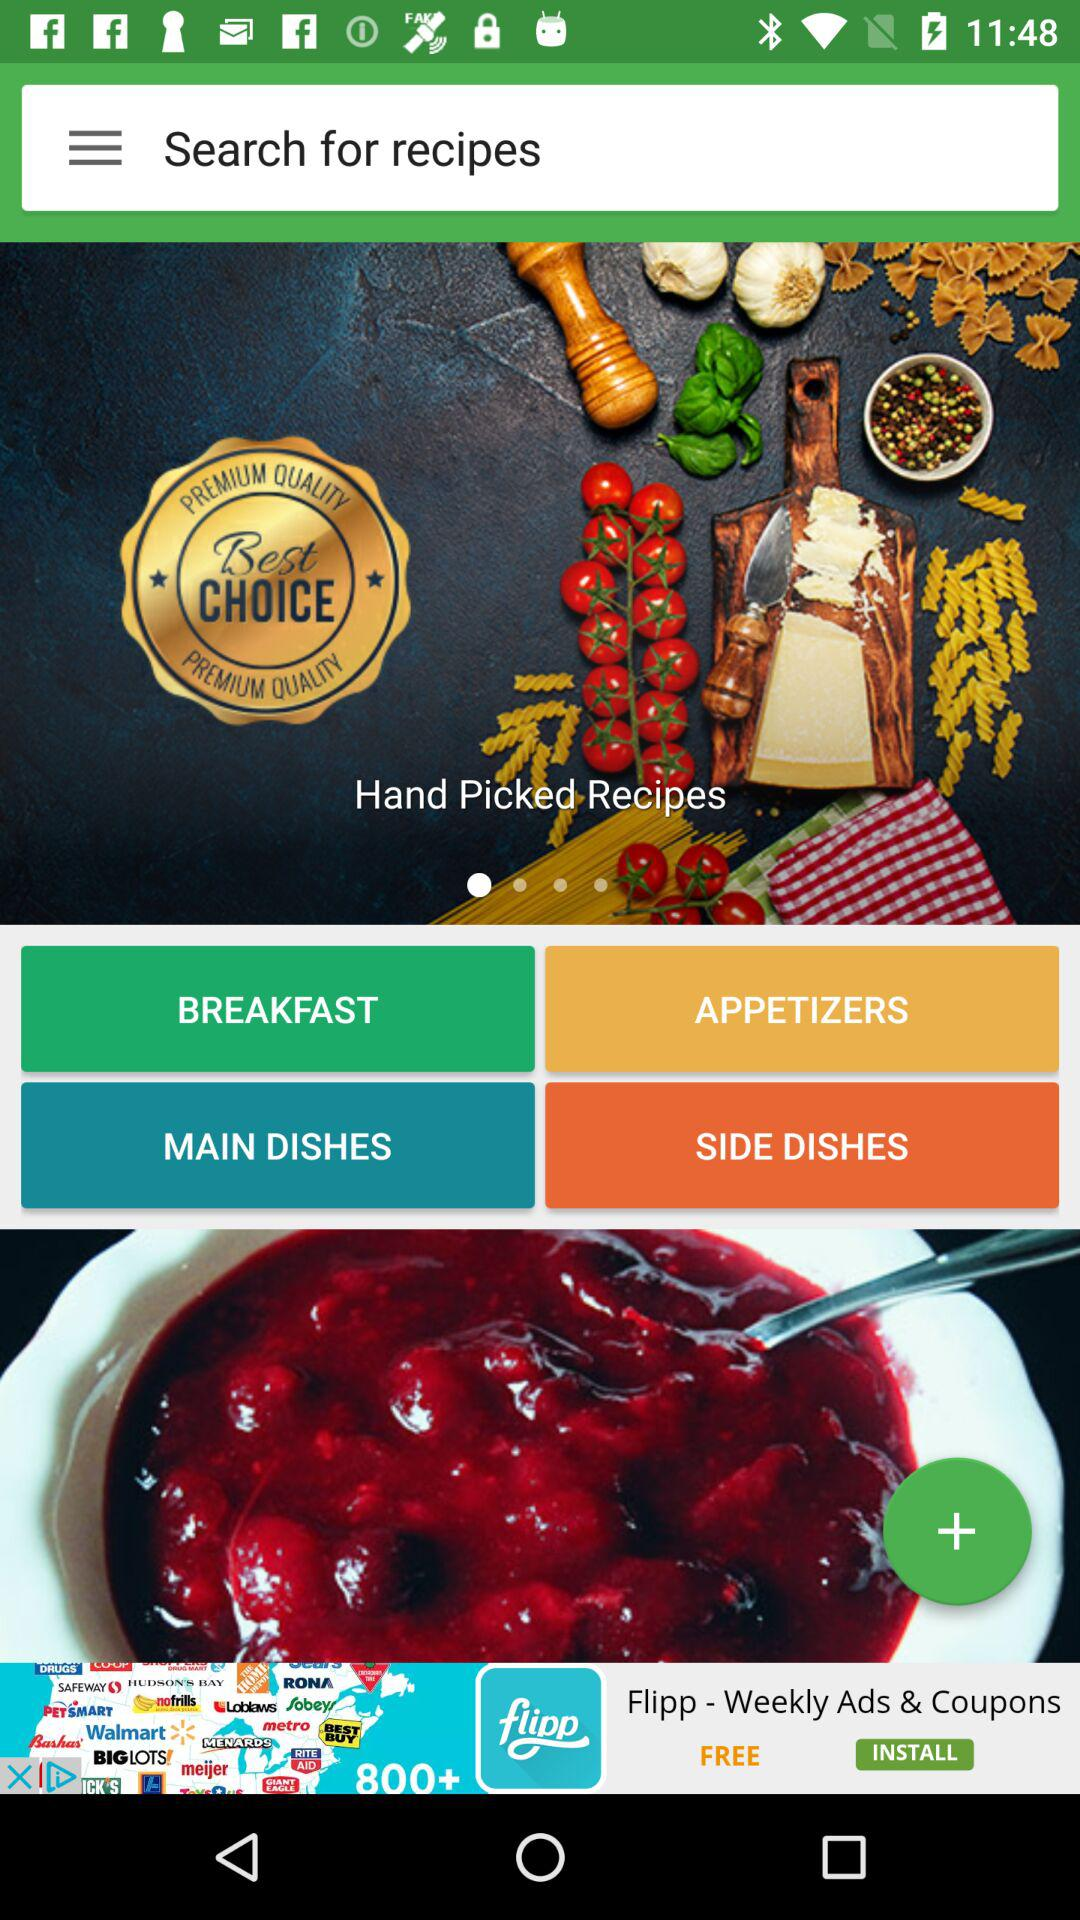What are the options in the menu? The options in the menu are "BREAKFAST", "APPETIZERS", "MAIN DISHES", and "SIDE DISHES". 